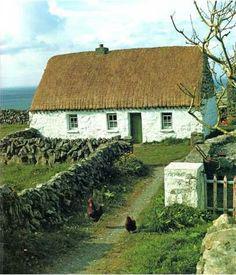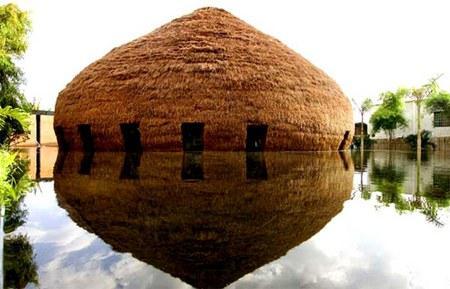The first image is the image on the left, the second image is the image on the right. For the images shown, is this caption "At least one of the buildings has shutters around the windows." true? Answer yes or no. No. 